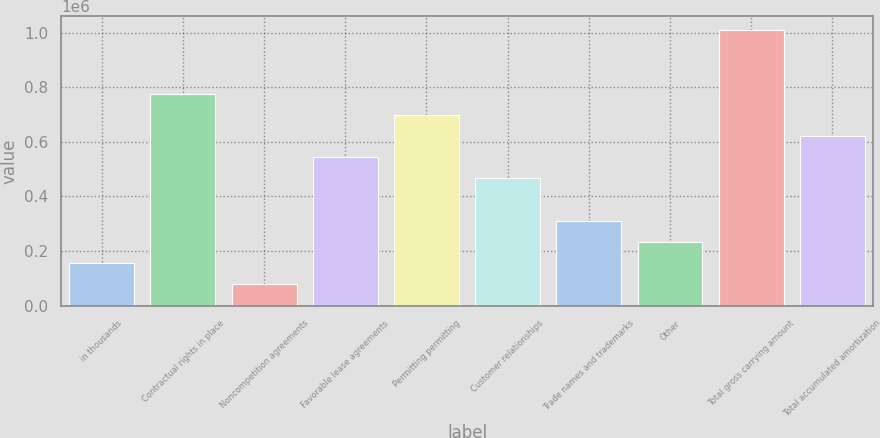<chart> <loc_0><loc_0><loc_500><loc_500><bar_chart><fcel>in thousands<fcel>Contractual rights in place<fcel>Noncompetition agreements<fcel>Favorable lease agreements<fcel>Permitting permitting<fcel>Customer relationships<fcel>Trade names and trademarks<fcel>Other<fcel>Total gross carrying amount<fcel>Total accumulated amortization<nl><fcel>155384<fcel>776909<fcel>77692.9<fcel>543837<fcel>699218<fcel>466146<fcel>310765<fcel>233074<fcel>1.00998e+06<fcel>621528<nl></chart> 